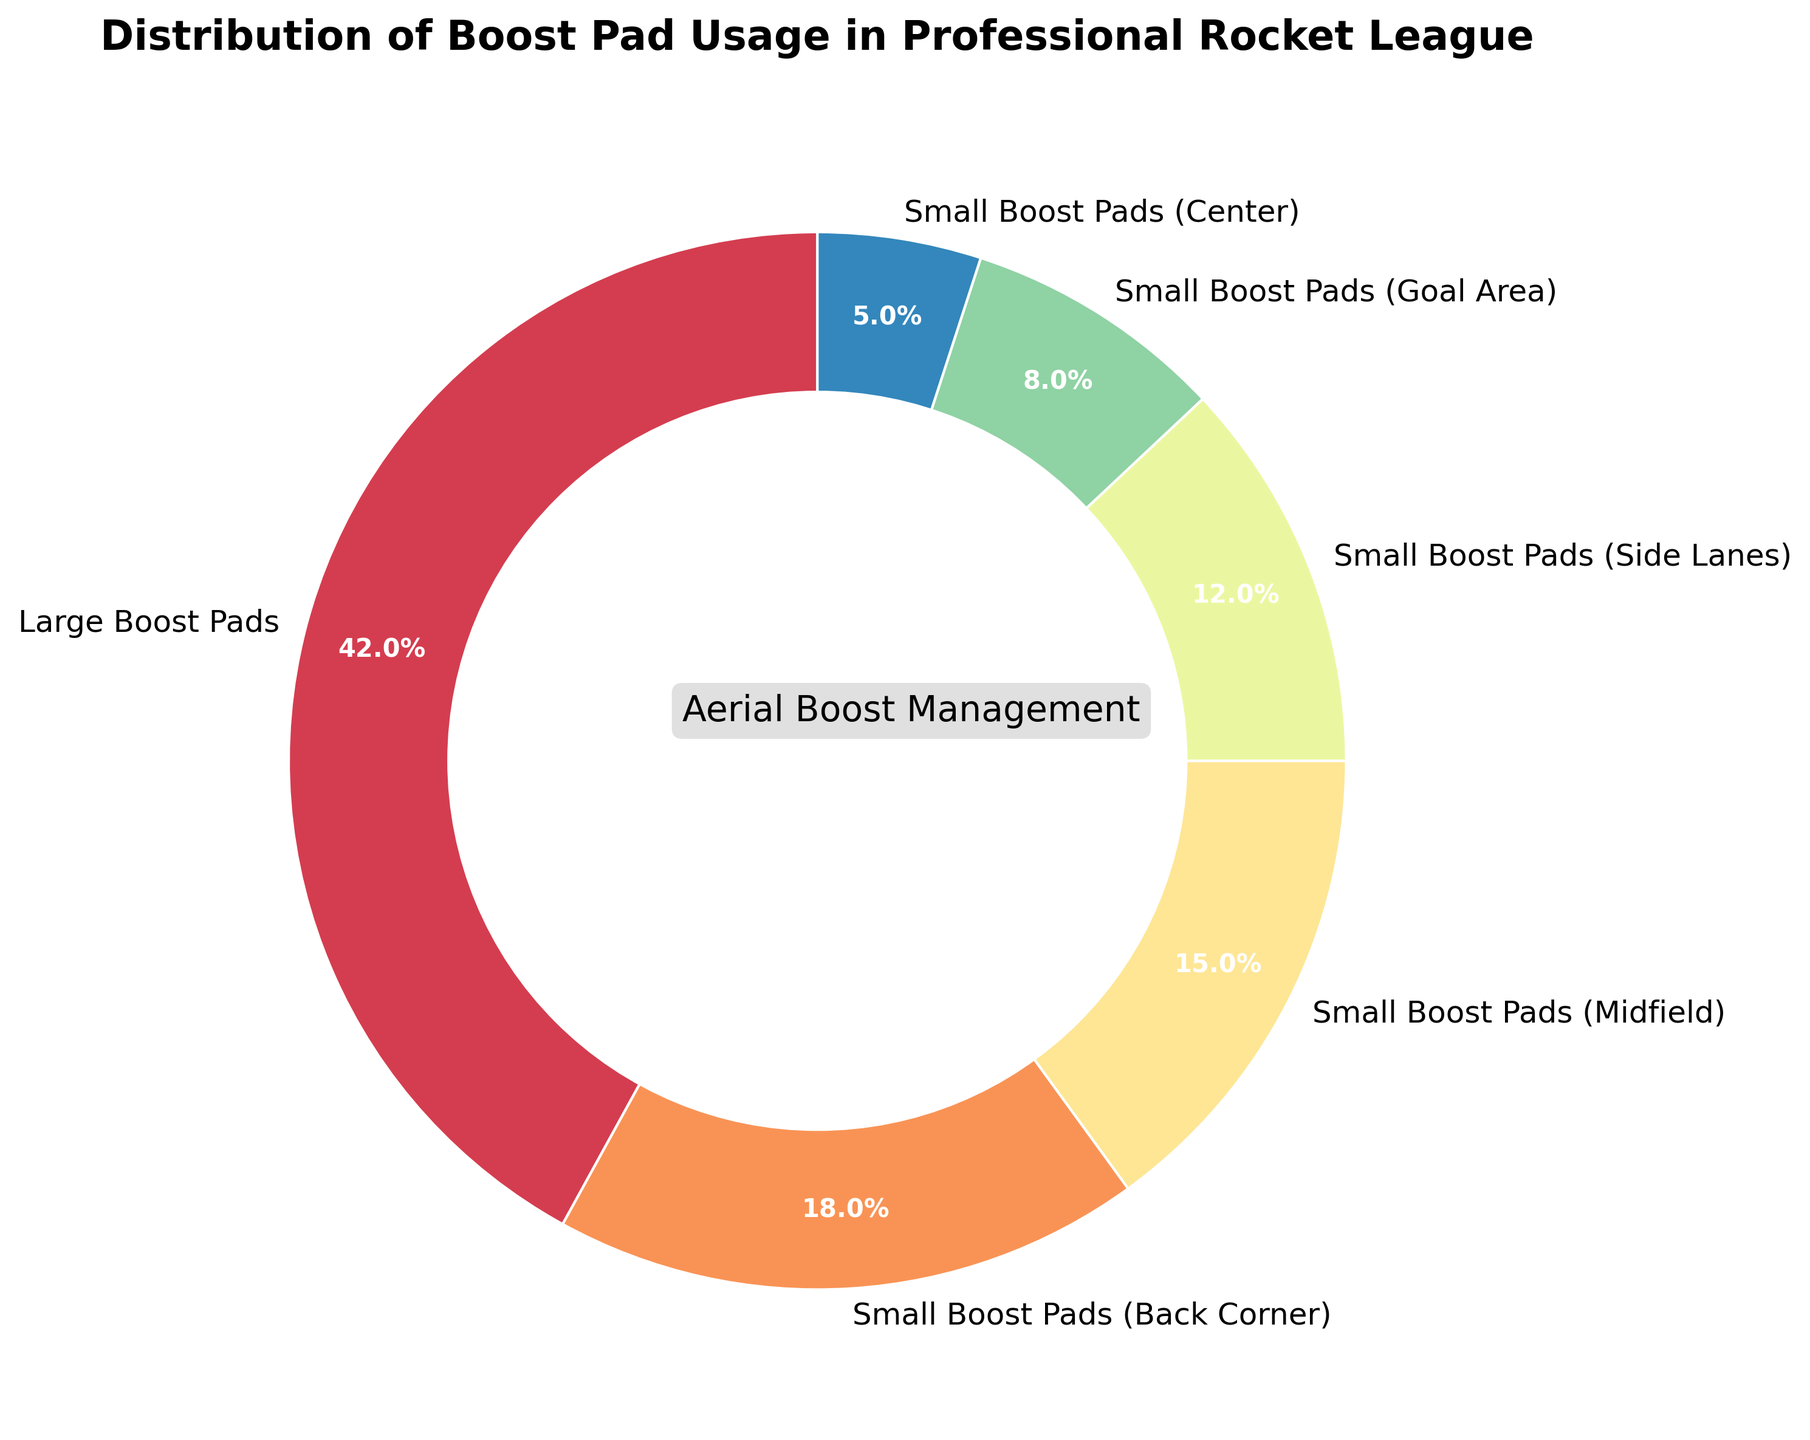what percentage of boost usage is from small boost pads in the midfield and goal area combined? Add the percentages of small boost pads (Midfield) and small boost pads (Goal Area). Midfield is 15%, Goal Area is 8%. So, 15% + 8% = 23%
Answer: 23% Which boost pad type is used the most? Look for the boost pad type with the highest percentage. Large Boost Pads have the highest percentage at 42%
Answer: Large Boost Pads Are small boost pads in back corners used more or less than small boost pads in side lanes? Compare the percentages of small boost pads (Back Corner) and small boost pads (Side Lanes). Back Corner is 18%, Side Lanes is 12%. 18% is greater than 12%
Answer: More What is the difference in usage between large boost pads and small boost pads in the center? Subtract the percentage of small boost pads (Center) from the percentage of large boost pads. 42% - 5% = 37%
Answer: 37% How do small boost pads in the midfield compare visually to those in the goal area in terms of the pie chart wedge size? Compare the wedges that represent small boost pads (Midfield) and small boost pads (Goal Area). The wedge for Midfield is larger than the wedge for Goal Area
Answer: Midfield wedge is larger Which small boost pad type has the lowest usage? Identify the small boost pad type with the smallest percentage. Small Boost Pads (Center) has the lowest usage at 5%
Answer: Small Boost Pads (Center) If you were combining all small boost pad usages, what percentage would that contribute to the overall usage? Sum the percentages of all small boost pad types. Back Corner (18%), Midfield (15%), Side Lanes (12%), Goal Area (8%), Center (5%). 18% + 15% + 12% + 8% + 5% = 58%
Answer: 58% How much more are large boost pads used compared to small boost pads in the side lanes? Subtract the percentage of small boost pads (Side Lanes) from large boost pads. 42% - 12% = 30%
Answer: 30% 